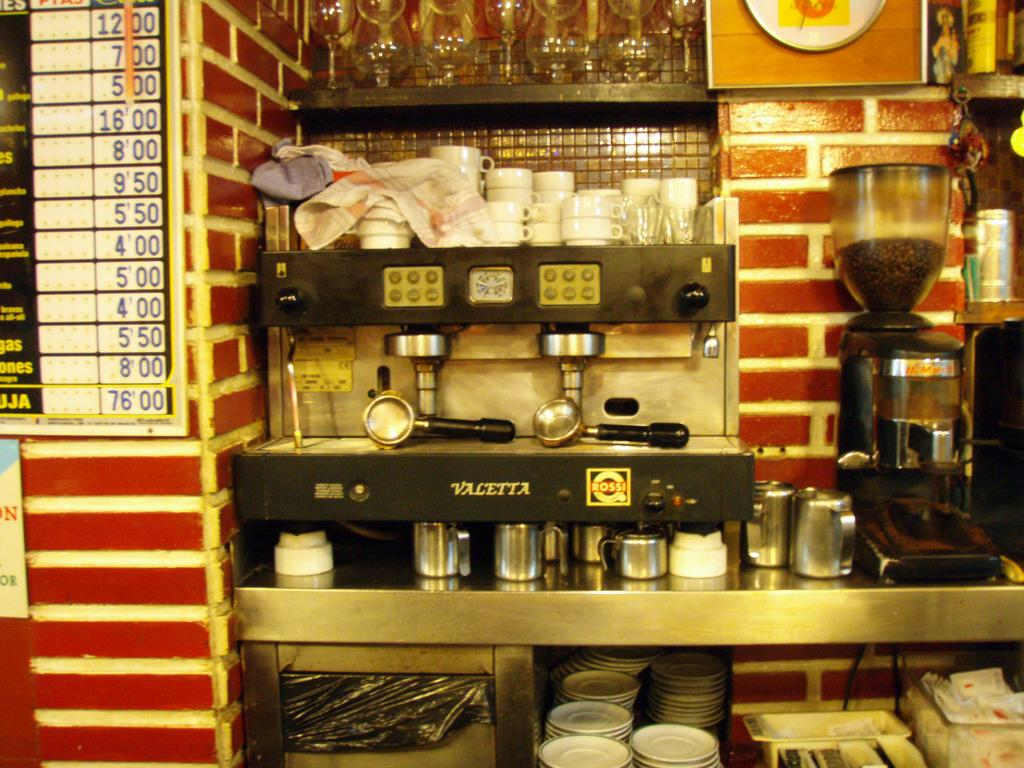<image>
Relay a brief, clear account of the picture shown. A Valetta ice cream machine next to a coffee machine. 